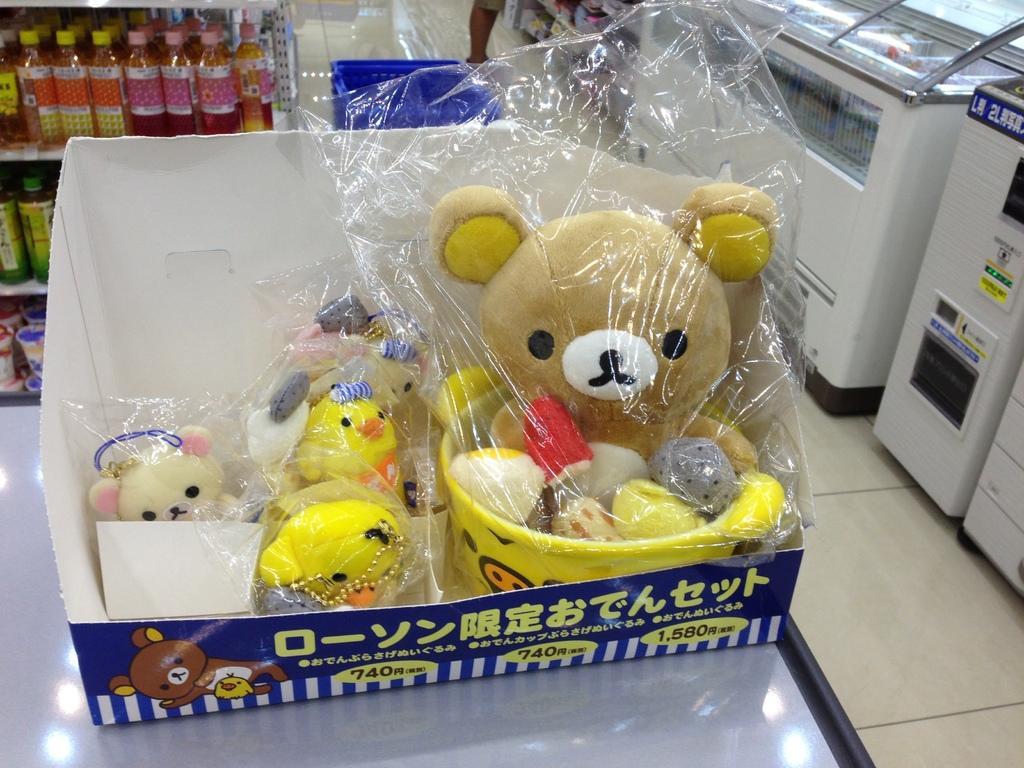Could you give a brief overview of what you see in this image? In this image, we can see some toys in the box which is on the table. There are some bottles in the rack. There are counters in the top right of the image. 